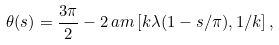Convert formula to latex. <formula><loc_0><loc_0><loc_500><loc_500>\theta ( s ) = \frac { 3 \pi } { 2 } - 2 \, a m \left [ k \lambda ( 1 - s / \pi ) , 1 / k \right ] ,</formula> 